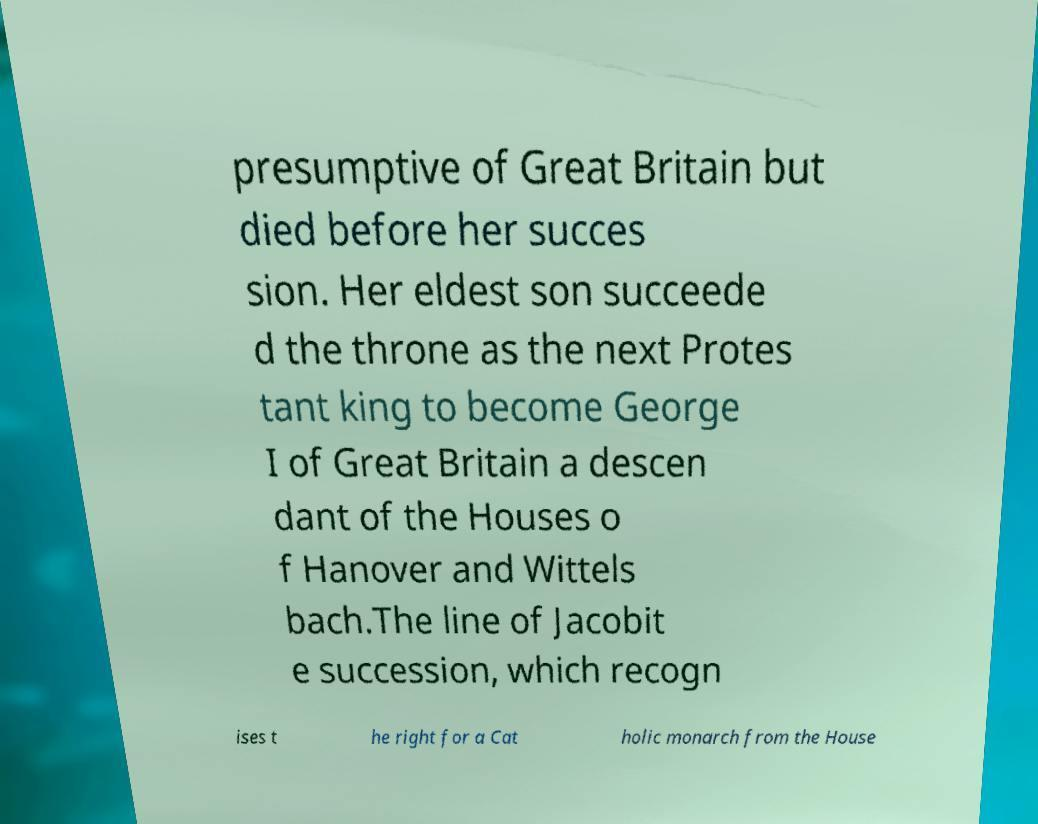Could you assist in decoding the text presented in this image and type it out clearly? presumptive of Great Britain but died before her succes sion. Her eldest son succeede d the throne as the next Protes tant king to become George I of Great Britain a descen dant of the Houses o f Hanover and Wittels bach.The line of Jacobit e succession, which recogn ises t he right for a Cat holic monarch from the House 